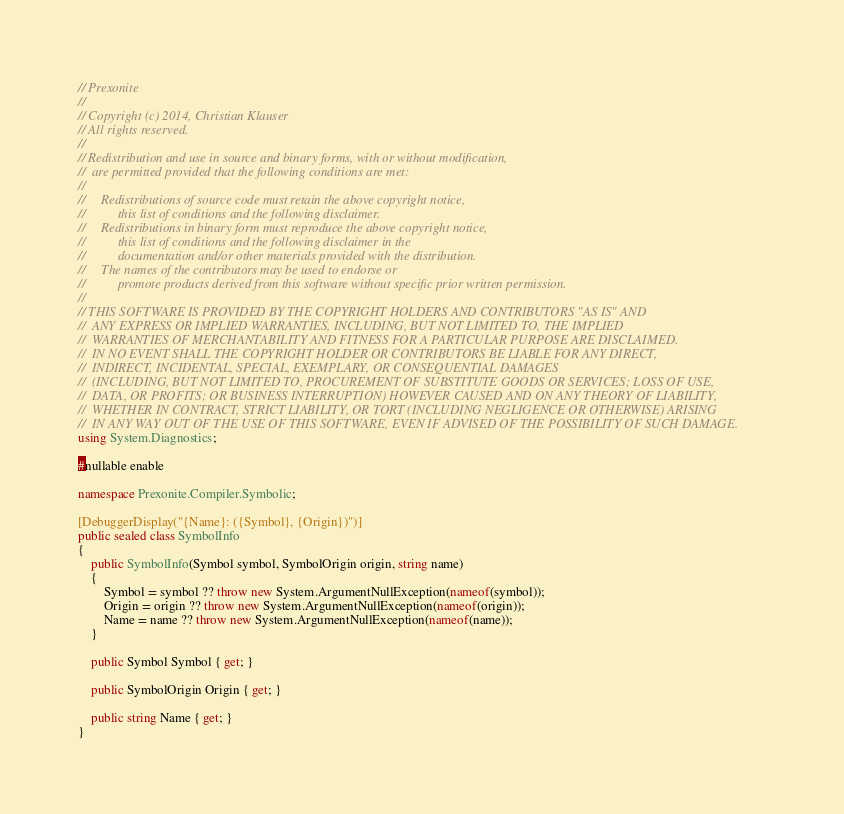Convert code to text. <code><loc_0><loc_0><loc_500><loc_500><_C#_>// Prexonite
// 
// Copyright (c) 2014, Christian Klauser
// All rights reserved.
// 
// Redistribution and use in source and binary forms, with or without modification, 
//  are permitted provided that the following conditions are met:
// 
//     Redistributions of source code must retain the above copyright notice, 
//          this list of conditions and the following disclaimer.
//     Redistributions in binary form must reproduce the above copyright notice, 
//          this list of conditions and the following disclaimer in the 
//          documentation and/or other materials provided with the distribution.
//     The names of the contributors may be used to endorse or 
//          promote products derived from this software without specific prior written permission.
// 
// THIS SOFTWARE IS PROVIDED BY THE COPYRIGHT HOLDERS AND CONTRIBUTORS "AS IS" AND 
//  ANY EXPRESS OR IMPLIED WARRANTIES, INCLUDING, BUT NOT LIMITED TO, THE IMPLIED 
//  WARRANTIES OF MERCHANTABILITY AND FITNESS FOR A PARTICULAR PURPOSE ARE DISCLAIMED. 
//  IN NO EVENT SHALL THE COPYRIGHT HOLDER OR CONTRIBUTORS BE LIABLE FOR ANY DIRECT, 
//  INDIRECT, INCIDENTAL, SPECIAL, EXEMPLARY, OR CONSEQUENTIAL DAMAGES 
//  (INCLUDING, BUT NOT LIMITED TO, PROCUREMENT OF SUBSTITUTE GOODS OR SERVICES; LOSS OF USE, 
//  DATA, OR PROFITS; OR BUSINESS INTERRUPTION) HOWEVER CAUSED AND ON ANY THEORY OF LIABILITY, 
//  WHETHER IN CONTRACT, STRICT LIABILITY, OR TORT (INCLUDING NEGLIGENCE OR OTHERWISE) ARISING 
//  IN ANY WAY OUT OF THE USE OF THIS SOFTWARE, EVEN IF ADVISED OF THE POSSIBILITY OF SUCH DAMAGE.
using System.Diagnostics;

#nullable enable

namespace Prexonite.Compiler.Symbolic;

[DebuggerDisplay("{Name}: ({Symbol}, {Origin})")]
public sealed class SymbolInfo
{
    public SymbolInfo(Symbol symbol, SymbolOrigin origin, string name)
    {
        Symbol = symbol ?? throw new System.ArgumentNullException(nameof(symbol));
        Origin = origin ?? throw new System.ArgumentNullException(nameof(origin));
        Name = name ?? throw new System.ArgumentNullException(nameof(name));
    }

    public Symbol Symbol { get; }

    public SymbolOrigin Origin { get; }

    public string Name { get; }
}</code> 